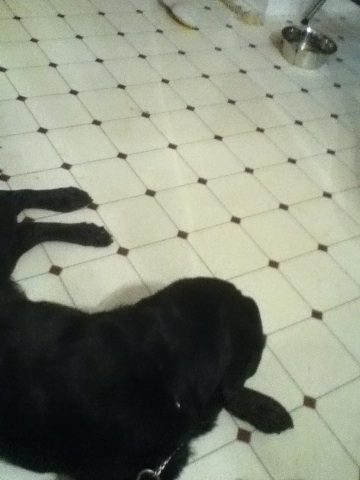What breed do you think the black dog might be? It's hard to say for certain from just the image, but the black dog might be a Labrador Retriever as they often have a similar appearance. Can you tell what the black dog might be feeling? The black dog appears to be lying down quietly. It might be feeling relaxed and comfortable in its surroundings. What do you think the other dog in the background is doing? The other dog, whose leg is partially visible, might be standing near the metal pet food bowl. It could be waiting to eat or drinking water. Do you have any fun facts about dogs? Sure! Did you know that dogs have three eyelids? They have an upper lid, a lower lid, and a third lid called a nictitating membrane or haw, which helps to keep their eyes moist and protected. 